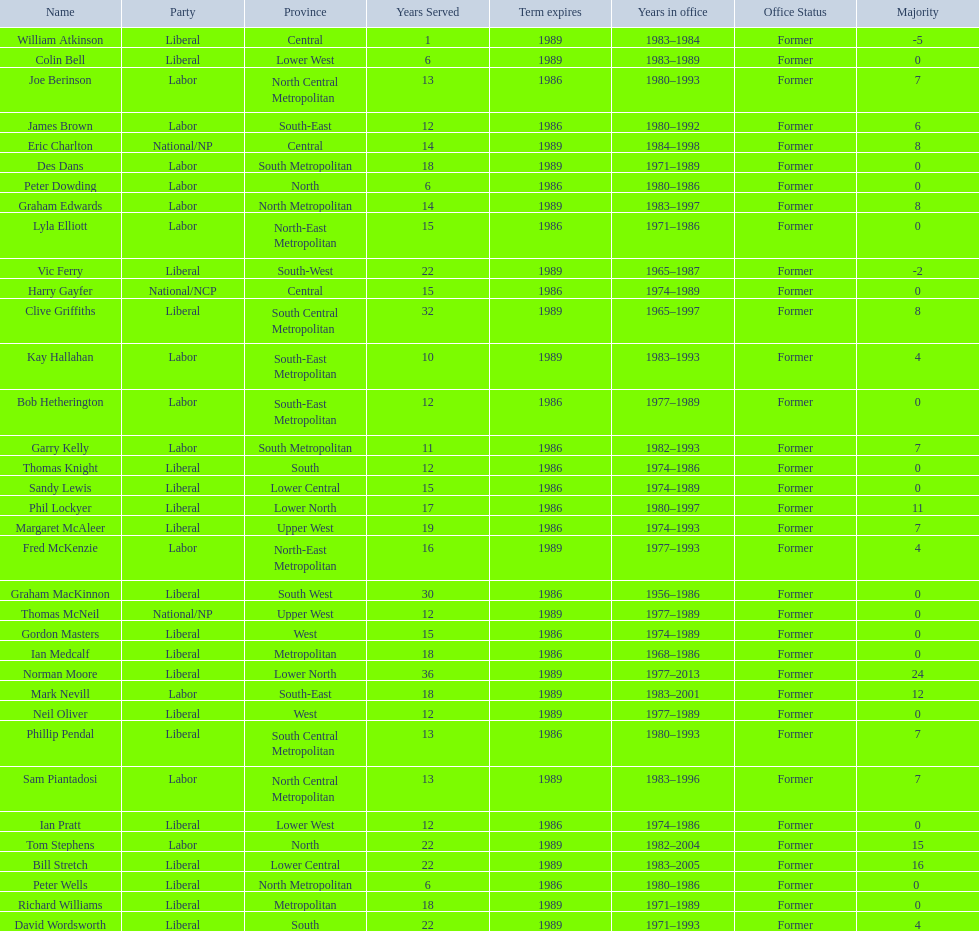Which party has the most membership? Liberal. 